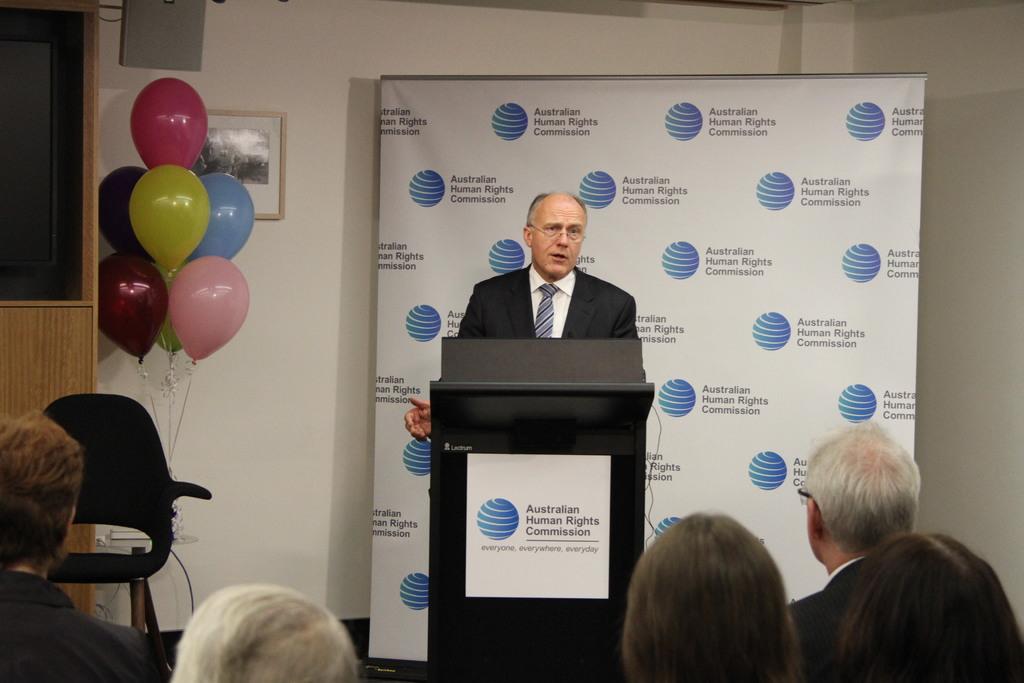What commission is this?
Offer a terse response. Australian human rights. 